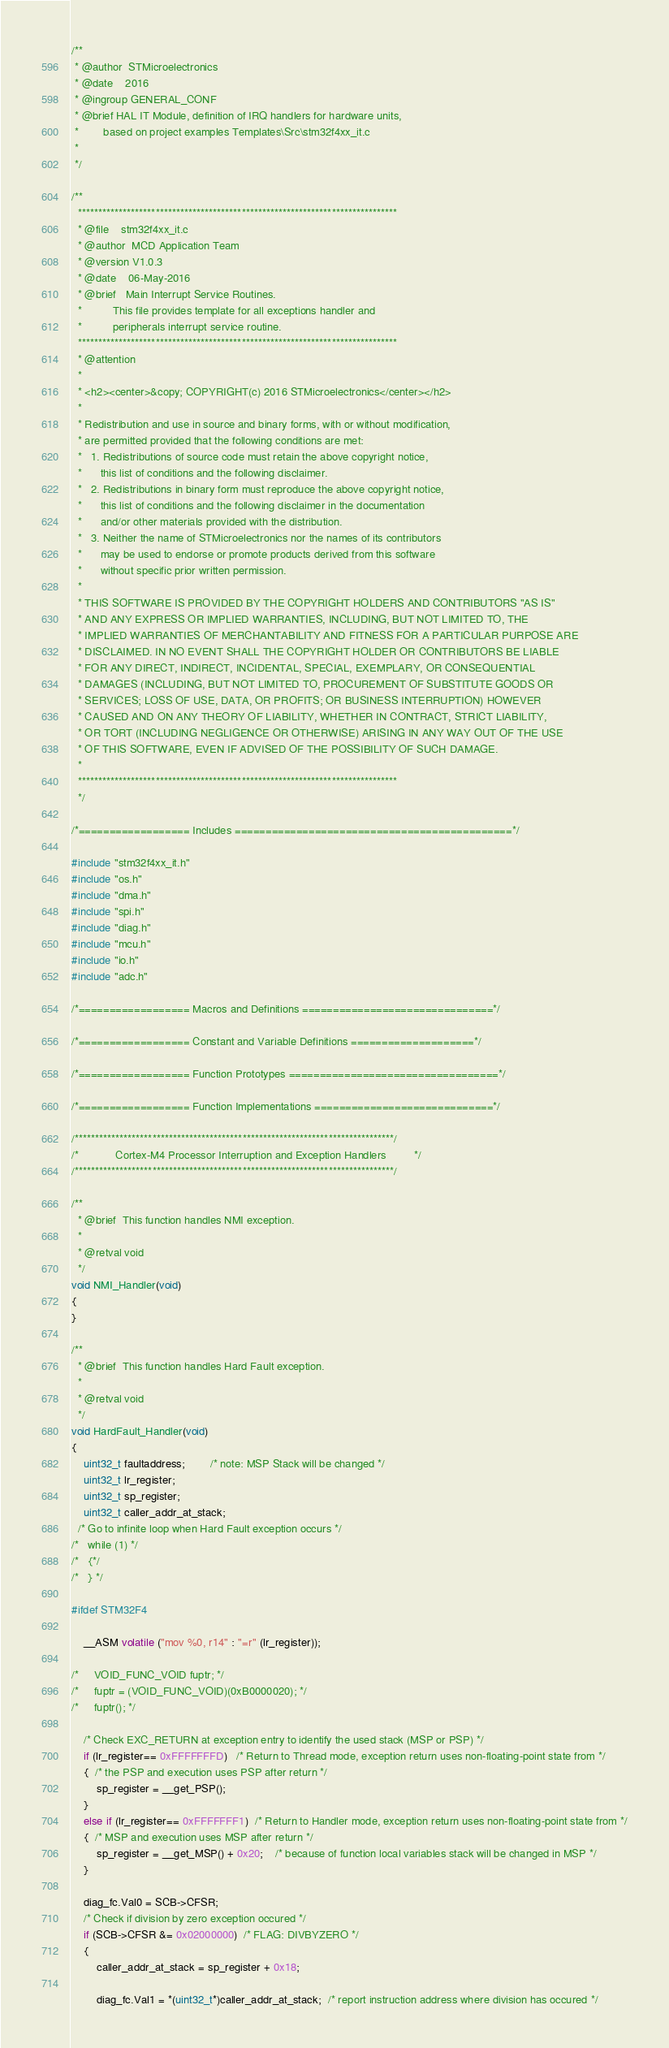<code> <loc_0><loc_0><loc_500><loc_500><_C_>/**
 * @author  STMicroelectronics
 * @date    2016
 * @ingroup GENERAL_CONF
 * @brief HAL IT Module, definition of IRQ handlers for hardware units,
 *        based on project examples Templates\Src\stm32f4xx_it.c    
 *
 */

/**
  ******************************************************************************
  * @file    stm32f4xx_it.c
  * @author  MCD Application Team
  * @version V1.0.3
  * @date    06-May-2016
  * @brief   Main Interrupt Service Routines.
  *          This file provides template for all exceptions handler and 
  *          peripherals interrupt service routine.
  ******************************************************************************
  * @attention
  *
  * <h2><center>&copy; COPYRIGHT(c) 2016 STMicroelectronics</center></h2>
  *
  * Redistribution and use in source and binary forms, with or without modification,
  * are permitted provided that the following conditions are met:
  *   1. Redistributions of source code must retain the above copyright notice,
  *      this list of conditions and the following disclaimer.
  *   2. Redistributions in binary form must reproduce the above copyright notice,
  *      this list of conditions and the following disclaimer in the documentation
  *      and/or other materials provided with the distribution.
  *   3. Neither the name of STMicroelectronics nor the names of its contributors
  *      may be used to endorse or promote products derived from this software
  *      without specific prior written permission.
  *
  * THIS SOFTWARE IS PROVIDED BY THE COPYRIGHT HOLDERS AND CONTRIBUTORS "AS IS"
  * AND ANY EXPRESS OR IMPLIED WARRANTIES, INCLUDING, BUT NOT LIMITED TO, THE
  * IMPLIED WARRANTIES OF MERCHANTABILITY AND FITNESS FOR A PARTICULAR PURPOSE ARE
  * DISCLAIMED. IN NO EVENT SHALL THE COPYRIGHT HOLDER OR CONTRIBUTORS BE LIABLE
  * FOR ANY DIRECT, INDIRECT, INCIDENTAL, SPECIAL, EXEMPLARY, OR CONSEQUENTIAL
  * DAMAGES (INCLUDING, BUT NOT LIMITED TO, PROCUREMENT OF SUBSTITUTE GOODS OR
  * SERVICES; LOSS OF USE, DATA, OR PROFITS; OR BUSINESS INTERRUPTION) HOWEVER
  * CAUSED AND ON ANY THEORY OF LIABILITY, WHETHER IN CONTRACT, STRICT LIABILITY,
  * OR TORT (INCLUDING NEGLIGENCE OR OTHERWISE) ARISING IN ANY WAY OUT OF THE USE
  * OF THIS SOFTWARE, EVEN IF ADVISED OF THE POSSIBILITY OF SUCH DAMAGE.
  *
  ******************************************************************************
  */

/*================== Includes =============================================*/

#include "stm32f4xx_it.h"
#include "os.h"
#include "dma.h"
#include "spi.h"
#include "diag.h"
#include "mcu.h"
#include "io.h"
#include "adc.h"

/*================== Macros and Definitions ===============================*/

/*================== Constant and Variable Definitions ====================*/

/*================== Function Prototypes ==================================*/

/*================== Function Implementations =============================*/

/******************************************************************************/
/*            Cortex-M4 Processor Interruption and Exception Handlers         */ 
/******************************************************************************/

/**
  * @brief  This function handles NMI exception.
  *
  * @retval void
  */
void NMI_Handler(void)
{
}

/**
  * @brief  This function handles Hard Fault exception.
  *
  * @retval void
  */
void HardFault_Handler(void)
{
    uint32_t faultaddress;        /* note: MSP Stack will be changed */
    uint32_t lr_register;
    uint32_t sp_register;
    uint32_t caller_addr_at_stack;
  /* Go to infinite loop when Hard Fault exception occurs */
/*   while (1) */
/*   {*/
/*   } */

#ifdef STM32F4

    __ASM volatile ("mov %0, r14" : "=r" (lr_register));

/*     VOID_FUNC_VOID fuptr; */
/*     fuptr = (VOID_FUNC_VOID)(0xB0000020); */
/*     fuptr(); */

    /* Check EXC_RETURN at exception entry to identify the used stack (MSP or PSP) */
    if (lr_register== 0xFFFFFFFD)   /* Return to Thread mode, exception return uses non-floating-point state from */
    {  /* the PSP and execution uses PSP after return */
        sp_register = __get_PSP();
    }
    else if (lr_register== 0xFFFFFFF1)  /* Return to Handler mode, exception return uses non-floating-point state from */
    {  /* MSP and execution uses MSP after return */
        sp_register = __get_MSP() + 0x20;    /* because of function local variables stack will be changed in MSP */
    }

    diag_fc.Val0 = SCB->CFSR;
    /* Check if division by zero exception occured */
    if (SCB->CFSR &= 0x02000000)  /* FLAG: DIVBYZERO */
    {
        caller_addr_at_stack = sp_register + 0x18;

        diag_fc.Val1 = *(uint32_t*)caller_addr_at_stack;  /* report instruction address where division has occured */</code> 